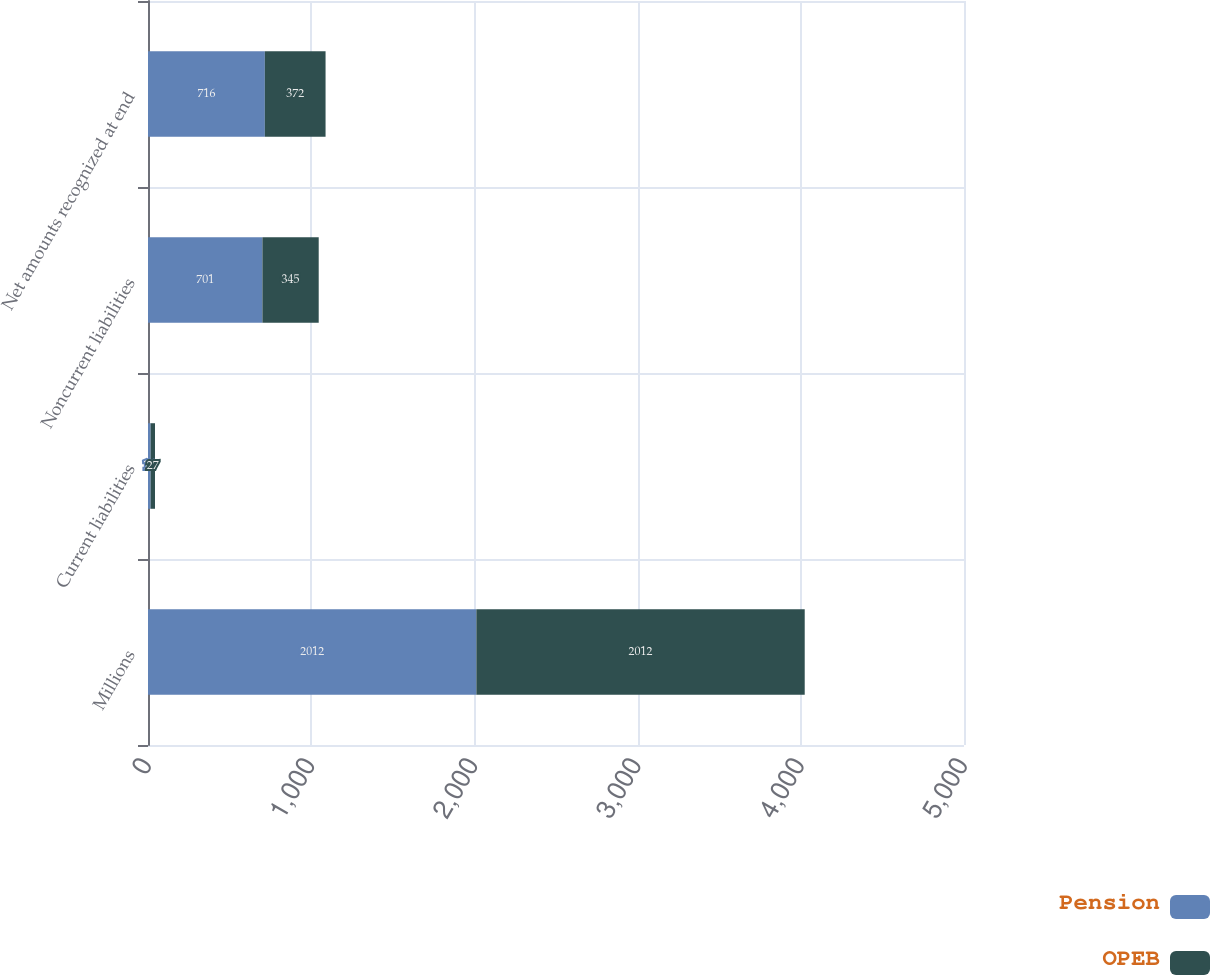<chart> <loc_0><loc_0><loc_500><loc_500><stacked_bar_chart><ecel><fcel>Millions<fcel>Current liabilities<fcel>Noncurrent liabilities<fcel>Net amounts recognized at end<nl><fcel>Pension<fcel>2012<fcel>16<fcel>701<fcel>716<nl><fcel>OPEB<fcel>2012<fcel>27<fcel>345<fcel>372<nl></chart> 